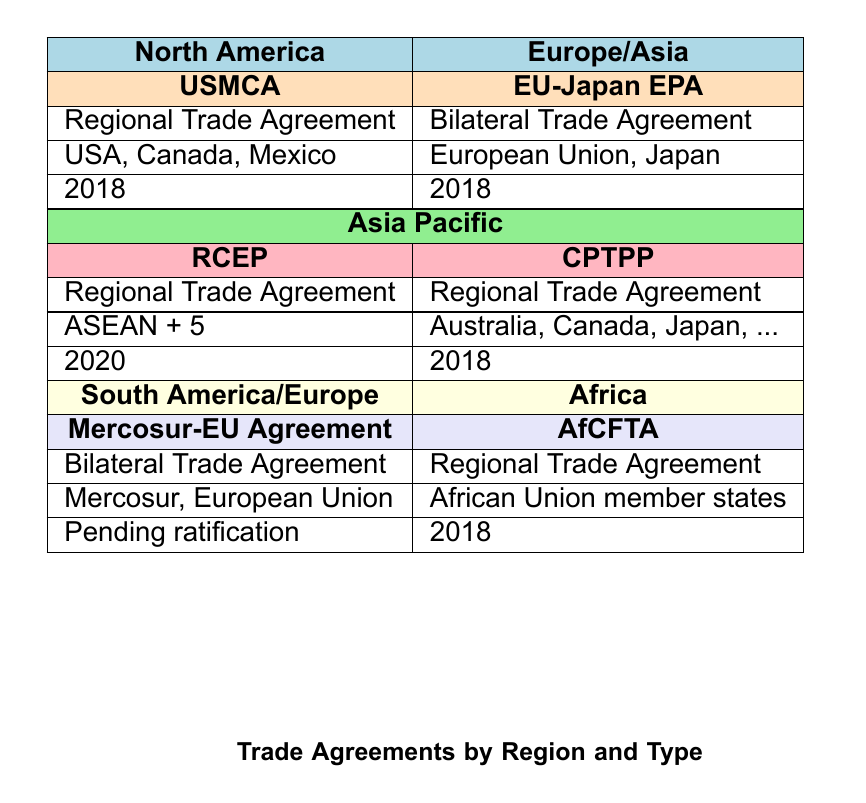What are the key features of the USMCA? The key features of the USMCA include tariff elimination on 99% of goods, increased labor protections, and environmental standards. This information is directly available in the row corresponding to the USMCA in the table.
Answer: Tariff elimination on 99% of goods, increased labor protections, environmental standards In which year was the RCEP signed? The year RCEP was signed can be found in the row for RCEP in the table, which states it was signed in 2020.
Answer: 2020 How many regional trade agreements are listed in the table? The table lists a total of four regional trade agreements: USMCA, RCEP, CPTPP, and AfCFTA. This can be determined by counting the instances labeled as "Regional Trade Agreement" in the 'type' column.
Answer: 4 Is the Mercosur-EU Agreement finalized? Based on the table, the row for the Mercosur-EU Agreement states it is "Pending ratification," indicating it is not yet finalized.
Answer: No What is the total number of members in the CPTPP? The CPTPP consists of nine member countries: Australia, Canada, Japan, Mexico, New Zealand, Singapore, Vietnam, Chile, and Peru. This information can be gathered from the corresponding row detailing the members of the CPTPP.
Answer: 9 How many regions have bilateral trade agreements listed? The table shows two regions with bilateral trade agreements: Europe/Asia (EU-Japan EPA) and South America/Europe (Mercosur-EU Agreement). By identifying the rows labeled as "Bilateral Trade Agreement," two regions can be confirmed.
Answer: 2 Which region has the earliest signed trade agreement? The earliest signed trade agreement in the table is the EU-Japan EPA and the USMCA, both signed in 2018. Identifying the 'year signed' for each agreement reveals that 2018 is the earliest year present in the data.
Answer: Europe/Asia and North America What are the key features of the AfCFTA? The key features can be found in the row for AfCFTA, listing elimination of tariffs on 90% of goods, facilitation of trade in services, and investment promotion. This data is expressly mentioned under the AfCFTA section in the table.
Answer: Elimination of tariffs on 90% of goods, facilitation of trade in services, investment promotion What is the total number of countries involved in trade agreements from Africa and Asia Pacific? For Africa, the AfCFTA involves all member states of the African Union, but it's not specified how many that are. For Asia Pacific (RCEP and CPTPP), we have 15 unique member countries (ASEAN + 5, plus 9 in CPTPP), totaling at least 24 unique countries across the two regions. More details on the exact count from Africa would require additional information not explicitly provided in the table.
Answer: At least 24 (but not confirmed for Africa) 